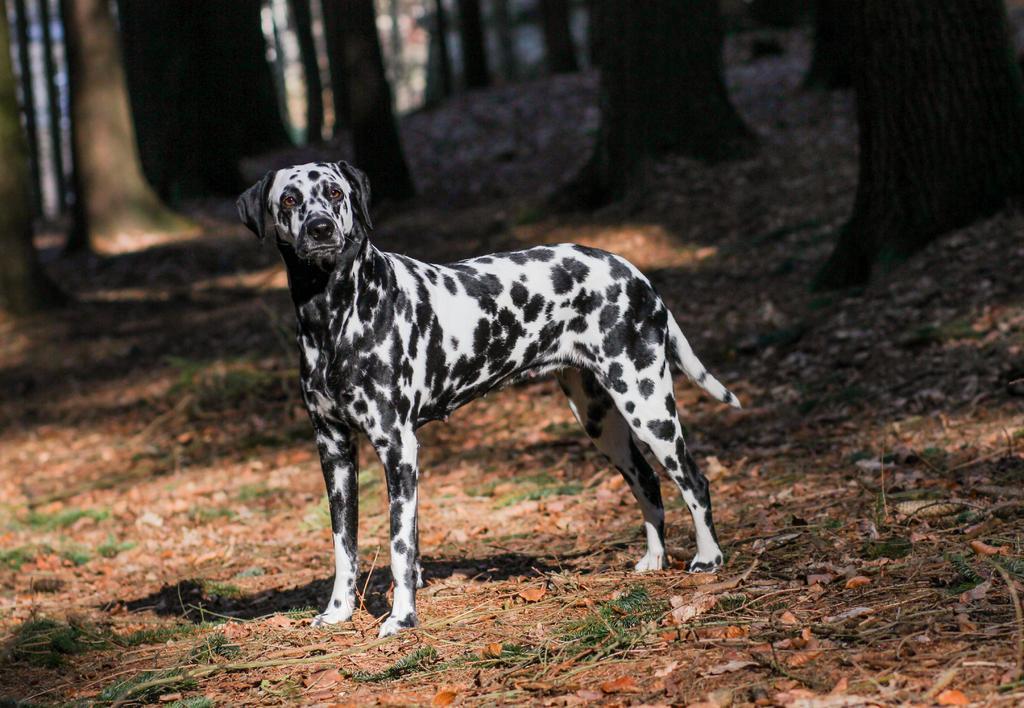Please provide a concise description of this image. In this image I can see a dog is in black and white color. At the top there are trees. 